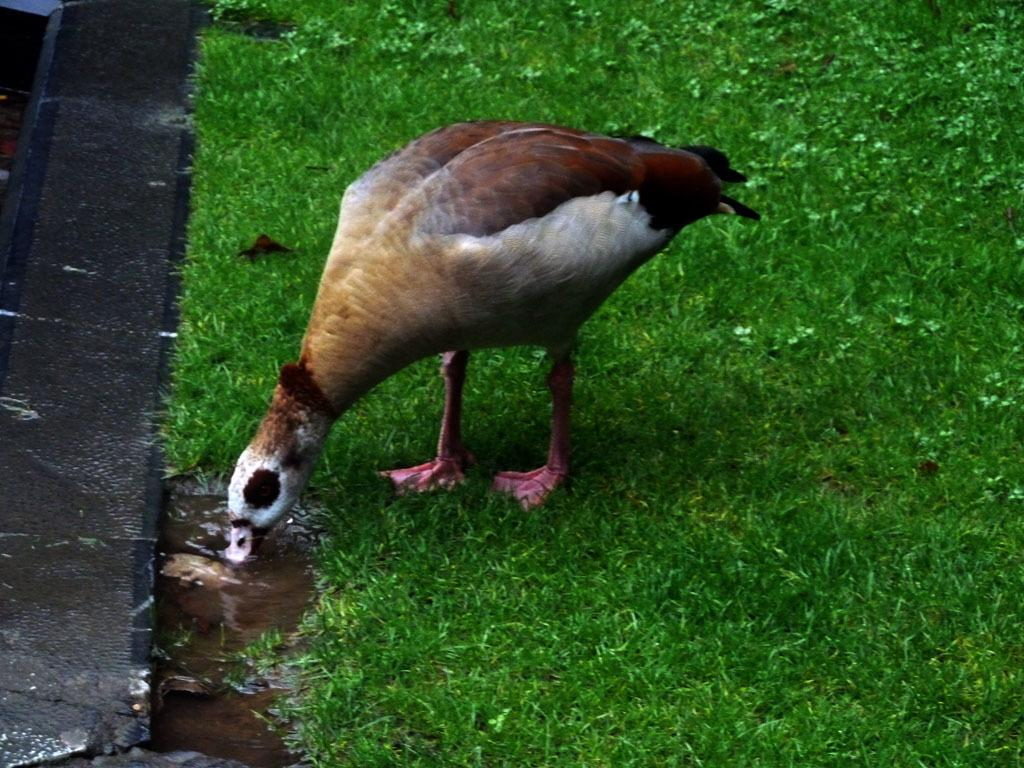What type of animal can be seen in the image? There is a bird in the image. Where is the bird located? The bird is standing on the grassland. What is the bird doing in the image? A: The bird is drinking water. What surface is visible in the image? There is a floor visible in the image. What word is the bird trying to spell out in the image? There is no indication in the image that the bird is trying to spell out a word. 